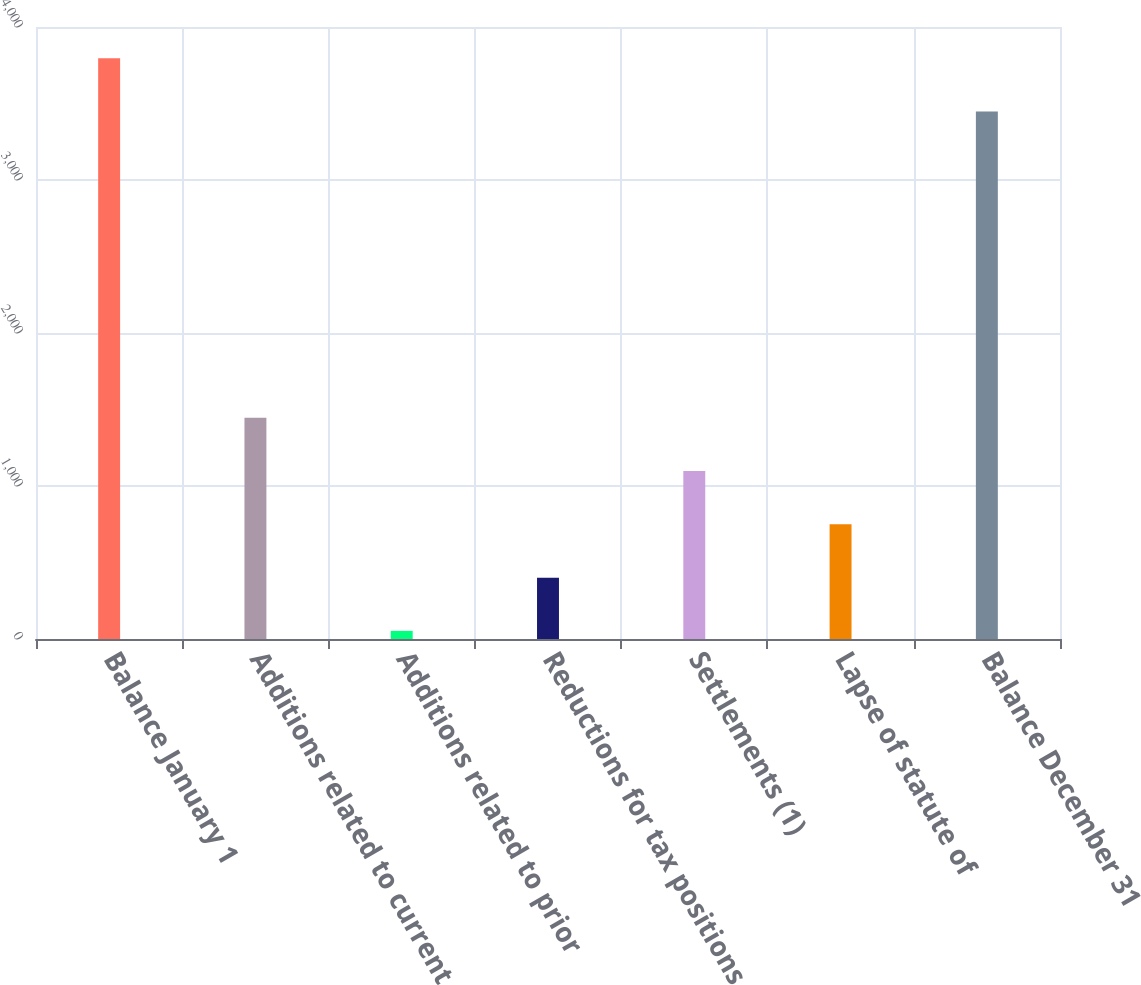Convert chart. <chart><loc_0><loc_0><loc_500><loc_500><bar_chart><fcel>Balance January 1<fcel>Additions related to current<fcel>Additions related to prior<fcel>Reductions for tax positions<fcel>Settlements (1)<fcel>Lapse of statute of<fcel>Balance December 31<nl><fcel>3796.1<fcel>1445.4<fcel>53<fcel>401.1<fcel>1097.3<fcel>749.2<fcel>3448<nl></chart> 